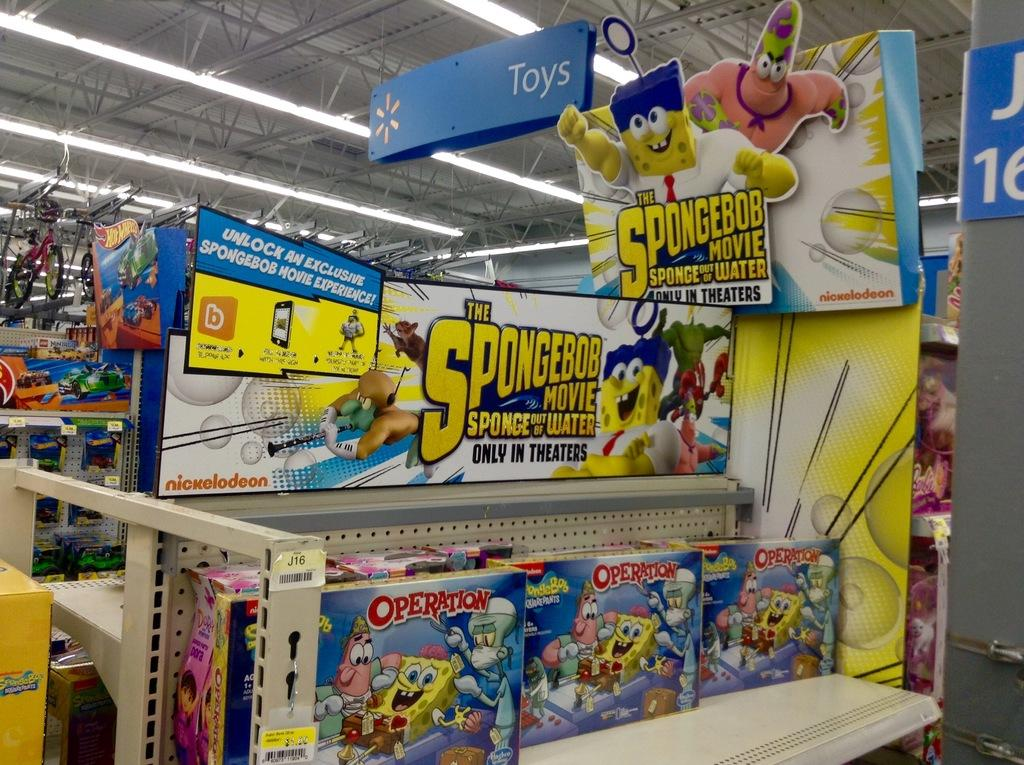<image>
Offer a succinct explanation of the picture presented. A Spongebob sign sits above a children's area with toys and movies. 